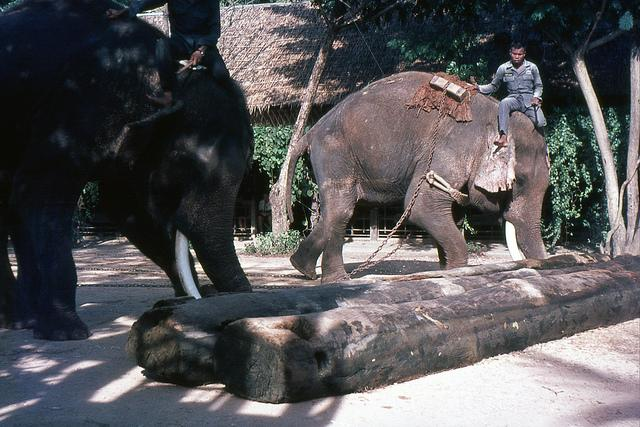What power will be used to move logs here? elephant 